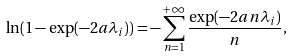Convert formula to latex. <formula><loc_0><loc_0><loc_500><loc_500>\ln ( 1 - \exp ( - 2 a \lambda _ { i } ) ) = - \sum _ { n = 1 } ^ { + \infty } \frac { \exp ( - 2 a n \lambda _ { i } ) } { n } ,</formula> 